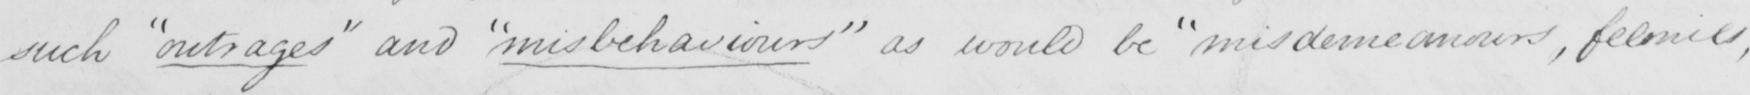Can you tell me what this handwritten text says? such  " outrages "  and  " misbehaviours "  as would be  " misdemeanors , felonies , 